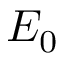Convert formula to latex. <formula><loc_0><loc_0><loc_500><loc_500>E _ { 0 }</formula> 